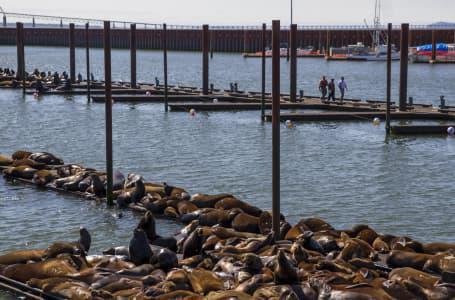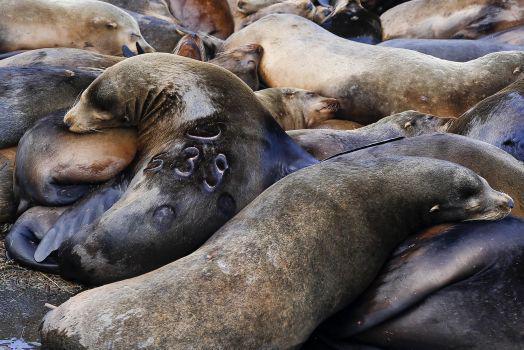The first image is the image on the left, the second image is the image on the right. Evaluate the accuracy of this statement regarding the images: "An image shows seals lying on a pier that has a narrow section extending out.". Is it true? Answer yes or no. Yes. 